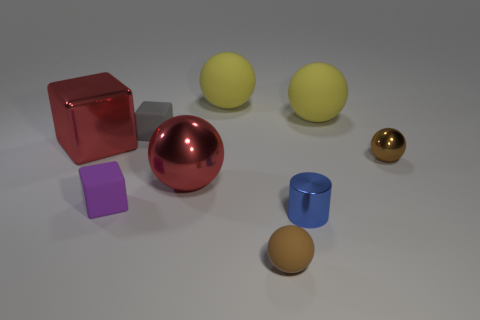Could you tell me what these objects are used for? These objects appear to be simple geometric shapes, perhaps used for educational purposes to teach about colors, shapes, and sizes, or they could be part of a visual composition exercise in an art or design context. 